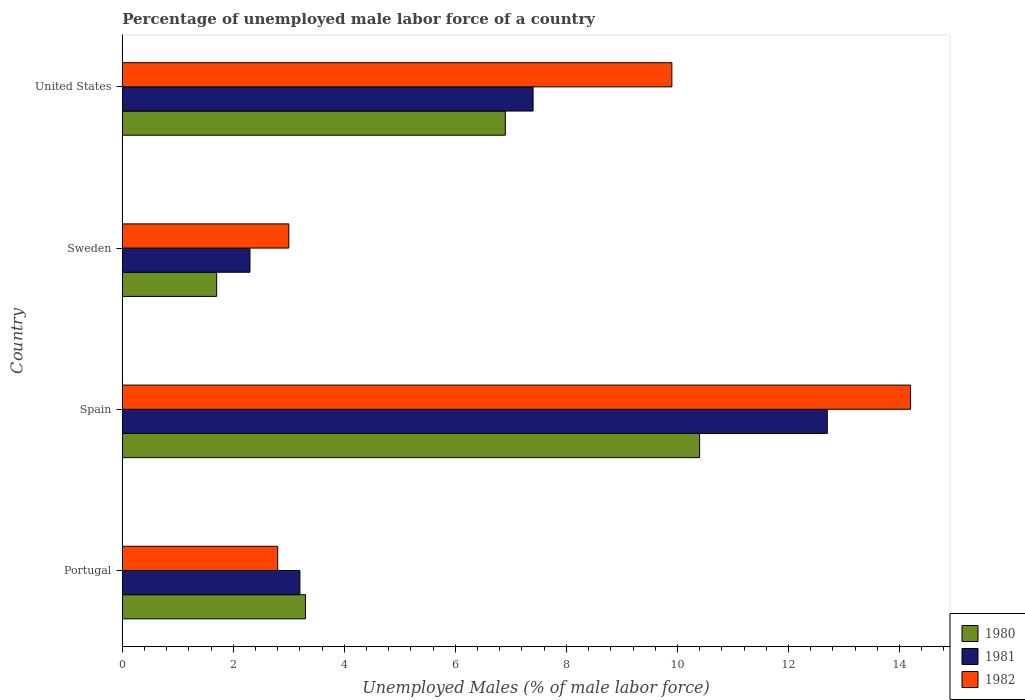How many different coloured bars are there?
Provide a succinct answer. 3. How many groups of bars are there?
Your response must be concise. 4. Are the number of bars on each tick of the Y-axis equal?
Provide a short and direct response. Yes. How many bars are there on the 3rd tick from the top?
Your response must be concise. 3. In how many cases, is the number of bars for a given country not equal to the number of legend labels?
Provide a succinct answer. 0. What is the percentage of unemployed male labor force in 1981 in Portugal?
Make the answer very short. 3.2. Across all countries, what is the maximum percentage of unemployed male labor force in 1980?
Give a very brief answer. 10.4. Across all countries, what is the minimum percentage of unemployed male labor force in 1980?
Your answer should be very brief. 1.7. In which country was the percentage of unemployed male labor force in 1980 minimum?
Offer a very short reply. Sweden. What is the total percentage of unemployed male labor force in 1981 in the graph?
Make the answer very short. 25.6. What is the difference between the percentage of unemployed male labor force in 1982 in Portugal and that in Spain?
Provide a succinct answer. -11.4. What is the difference between the percentage of unemployed male labor force in 1981 in United States and the percentage of unemployed male labor force in 1980 in Portugal?
Give a very brief answer. 4.1. What is the average percentage of unemployed male labor force in 1981 per country?
Your answer should be very brief. 6.4. What is the difference between the percentage of unemployed male labor force in 1981 and percentage of unemployed male labor force in 1982 in Spain?
Keep it short and to the point. -1.5. What is the ratio of the percentage of unemployed male labor force in 1981 in Portugal to that in Sweden?
Provide a short and direct response. 1.39. Is the percentage of unemployed male labor force in 1981 in Portugal less than that in Spain?
Give a very brief answer. Yes. Is the difference between the percentage of unemployed male labor force in 1981 in Spain and United States greater than the difference between the percentage of unemployed male labor force in 1982 in Spain and United States?
Your answer should be very brief. Yes. What is the difference between the highest and the second highest percentage of unemployed male labor force in 1980?
Ensure brevity in your answer.  3.5. What is the difference between the highest and the lowest percentage of unemployed male labor force in 1980?
Keep it short and to the point. 8.7. In how many countries, is the percentage of unemployed male labor force in 1980 greater than the average percentage of unemployed male labor force in 1980 taken over all countries?
Give a very brief answer. 2. What does the 3rd bar from the top in United States represents?
Offer a terse response. 1980. Are the values on the major ticks of X-axis written in scientific E-notation?
Your response must be concise. No. Does the graph contain any zero values?
Your response must be concise. No. How many legend labels are there?
Your response must be concise. 3. What is the title of the graph?
Keep it short and to the point. Percentage of unemployed male labor force of a country. What is the label or title of the X-axis?
Your answer should be compact. Unemployed Males (% of male labor force). What is the label or title of the Y-axis?
Give a very brief answer. Country. What is the Unemployed Males (% of male labor force) of 1980 in Portugal?
Keep it short and to the point. 3.3. What is the Unemployed Males (% of male labor force) in 1981 in Portugal?
Keep it short and to the point. 3.2. What is the Unemployed Males (% of male labor force) of 1982 in Portugal?
Give a very brief answer. 2.8. What is the Unemployed Males (% of male labor force) of 1980 in Spain?
Your answer should be compact. 10.4. What is the Unemployed Males (% of male labor force) of 1981 in Spain?
Make the answer very short. 12.7. What is the Unemployed Males (% of male labor force) in 1982 in Spain?
Keep it short and to the point. 14.2. What is the Unemployed Males (% of male labor force) in 1980 in Sweden?
Provide a short and direct response. 1.7. What is the Unemployed Males (% of male labor force) in 1981 in Sweden?
Offer a terse response. 2.3. What is the Unemployed Males (% of male labor force) in 1982 in Sweden?
Your response must be concise. 3. What is the Unemployed Males (% of male labor force) of 1980 in United States?
Your response must be concise. 6.9. What is the Unemployed Males (% of male labor force) in 1981 in United States?
Keep it short and to the point. 7.4. What is the Unemployed Males (% of male labor force) of 1982 in United States?
Give a very brief answer. 9.9. Across all countries, what is the maximum Unemployed Males (% of male labor force) in 1980?
Your response must be concise. 10.4. Across all countries, what is the maximum Unemployed Males (% of male labor force) of 1981?
Your answer should be compact. 12.7. Across all countries, what is the maximum Unemployed Males (% of male labor force) in 1982?
Your answer should be very brief. 14.2. Across all countries, what is the minimum Unemployed Males (% of male labor force) in 1980?
Offer a terse response. 1.7. Across all countries, what is the minimum Unemployed Males (% of male labor force) of 1981?
Keep it short and to the point. 2.3. Across all countries, what is the minimum Unemployed Males (% of male labor force) in 1982?
Provide a short and direct response. 2.8. What is the total Unemployed Males (% of male labor force) of 1980 in the graph?
Provide a short and direct response. 22.3. What is the total Unemployed Males (% of male labor force) in 1981 in the graph?
Provide a short and direct response. 25.6. What is the total Unemployed Males (% of male labor force) in 1982 in the graph?
Provide a short and direct response. 29.9. What is the difference between the Unemployed Males (% of male labor force) in 1980 in Portugal and that in Spain?
Offer a very short reply. -7.1. What is the difference between the Unemployed Males (% of male labor force) in 1981 in Portugal and that in Spain?
Give a very brief answer. -9.5. What is the difference between the Unemployed Males (% of male labor force) in 1982 in Portugal and that in Spain?
Offer a very short reply. -11.4. What is the difference between the Unemployed Males (% of male labor force) in 1980 in Portugal and that in Sweden?
Your answer should be compact. 1.6. What is the difference between the Unemployed Males (% of male labor force) of 1981 in Portugal and that in Sweden?
Your answer should be compact. 0.9. What is the difference between the Unemployed Males (% of male labor force) in 1982 in Portugal and that in Sweden?
Offer a very short reply. -0.2. What is the difference between the Unemployed Males (% of male labor force) of 1980 in Portugal and that in United States?
Make the answer very short. -3.6. What is the difference between the Unemployed Males (% of male labor force) in 1982 in Portugal and that in United States?
Your answer should be very brief. -7.1. What is the difference between the Unemployed Males (% of male labor force) of 1981 in Sweden and that in United States?
Give a very brief answer. -5.1. What is the difference between the Unemployed Males (% of male labor force) of 1980 in Portugal and the Unemployed Males (% of male labor force) of 1981 in Spain?
Your answer should be very brief. -9.4. What is the difference between the Unemployed Males (% of male labor force) of 1980 in Portugal and the Unemployed Males (% of male labor force) of 1982 in Spain?
Ensure brevity in your answer.  -10.9. What is the difference between the Unemployed Males (% of male labor force) in 1981 in Portugal and the Unemployed Males (% of male labor force) in 1982 in Spain?
Ensure brevity in your answer.  -11. What is the difference between the Unemployed Males (% of male labor force) of 1980 in Portugal and the Unemployed Males (% of male labor force) of 1982 in Sweden?
Give a very brief answer. 0.3. What is the difference between the Unemployed Males (% of male labor force) of 1981 in Portugal and the Unemployed Males (% of male labor force) of 1982 in Sweden?
Your answer should be compact. 0.2. What is the difference between the Unemployed Males (% of male labor force) in 1980 in Portugal and the Unemployed Males (% of male labor force) in 1982 in United States?
Keep it short and to the point. -6.6. What is the difference between the Unemployed Males (% of male labor force) of 1980 in Spain and the Unemployed Males (% of male labor force) of 1981 in Sweden?
Ensure brevity in your answer.  8.1. What is the difference between the Unemployed Males (% of male labor force) in 1980 in Spain and the Unemployed Males (% of male labor force) in 1982 in Sweden?
Make the answer very short. 7.4. What is the difference between the Unemployed Males (% of male labor force) of 1981 in Spain and the Unemployed Males (% of male labor force) of 1982 in United States?
Give a very brief answer. 2.8. What is the average Unemployed Males (% of male labor force) in 1980 per country?
Your response must be concise. 5.58. What is the average Unemployed Males (% of male labor force) of 1981 per country?
Your answer should be very brief. 6.4. What is the average Unemployed Males (% of male labor force) of 1982 per country?
Ensure brevity in your answer.  7.47. What is the difference between the Unemployed Males (% of male labor force) of 1980 and Unemployed Males (% of male labor force) of 1981 in Portugal?
Your answer should be compact. 0.1. What is the difference between the Unemployed Males (% of male labor force) of 1981 and Unemployed Males (% of male labor force) of 1982 in Portugal?
Provide a short and direct response. 0.4. What is the difference between the Unemployed Males (% of male labor force) of 1980 and Unemployed Males (% of male labor force) of 1981 in Spain?
Your answer should be compact. -2.3. What is the difference between the Unemployed Males (% of male labor force) in 1981 and Unemployed Males (% of male labor force) in 1982 in Spain?
Provide a short and direct response. -1.5. What is the difference between the Unemployed Males (% of male labor force) in 1981 and Unemployed Males (% of male labor force) in 1982 in Sweden?
Provide a short and direct response. -0.7. What is the difference between the Unemployed Males (% of male labor force) of 1981 and Unemployed Males (% of male labor force) of 1982 in United States?
Offer a terse response. -2.5. What is the ratio of the Unemployed Males (% of male labor force) of 1980 in Portugal to that in Spain?
Provide a short and direct response. 0.32. What is the ratio of the Unemployed Males (% of male labor force) of 1981 in Portugal to that in Spain?
Offer a very short reply. 0.25. What is the ratio of the Unemployed Males (% of male labor force) in 1982 in Portugal to that in Spain?
Your response must be concise. 0.2. What is the ratio of the Unemployed Males (% of male labor force) in 1980 in Portugal to that in Sweden?
Offer a very short reply. 1.94. What is the ratio of the Unemployed Males (% of male labor force) in 1981 in Portugal to that in Sweden?
Give a very brief answer. 1.39. What is the ratio of the Unemployed Males (% of male labor force) of 1980 in Portugal to that in United States?
Provide a succinct answer. 0.48. What is the ratio of the Unemployed Males (% of male labor force) of 1981 in Portugal to that in United States?
Give a very brief answer. 0.43. What is the ratio of the Unemployed Males (% of male labor force) in 1982 in Portugal to that in United States?
Provide a succinct answer. 0.28. What is the ratio of the Unemployed Males (% of male labor force) of 1980 in Spain to that in Sweden?
Offer a terse response. 6.12. What is the ratio of the Unemployed Males (% of male labor force) in 1981 in Spain to that in Sweden?
Keep it short and to the point. 5.52. What is the ratio of the Unemployed Males (% of male labor force) in 1982 in Spain to that in Sweden?
Your answer should be very brief. 4.73. What is the ratio of the Unemployed Males (% of male labor force) of 1980 in Spain to that in United States?
Your answer should be very brief. 1.51. What is the ratio of the Unemployed Males (% of male labor force) in 1981 in Spain to that in United States?
Offer a terse response. 1.72. What is the ratio of the Unemployed Males (% of male labor force) in 1982 in Spain to that in United States?
Offer a terse response. 1.43. What is the ratio of the Unemployed Males (% of male labor force) in 1980 in Sweden to that in United States?
Offer a very short reply. 0.25. What is the ratio of the Unemployed Males (% of male labor force) in 1981 in Sweden to that in United States?
Provide a succinct answer. 0.31. What is the ratio of the Unemployed Males (% of male labor force) of 1982 in Sweden to that in United States?
Offer a terse response. 0.3. What is the difference between the highest and the second highest Unemployed Males (% of male labor force) in 1980?
Ensure brevity in your answer.  3.5. What is the difference between the highest and the second highest Unemployed Males (% of male labor force) of 1982?
Make the answer very short. 4.3. What is the difference between the highest and the lowest Unemployed Males (% of male labor force) in 1980?
Make the answer very short. 8.7. 